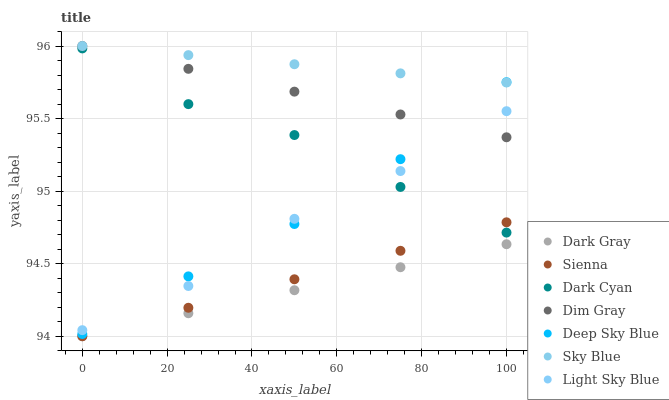Does Dark Gray have the minimum area under the curve?
Answer yes or no. Yes. Does Sky Blue have the maximum area under the curve?
Answer yes or no. Yes. Does Dim Gray have the minimum area under the curve?
Answer yes or no. No. Does Dim Gray have the maximum area under the curve?
Answer yes or no. No. Is Dark Gray the smoothest?
Answer yes or no. Yes. Is Light Sky Blue the roughest?
Answer yes or no. Yes. Is Dim Gray the smoothest?
Answer yes or no. No. Is Dim Gray the roughest?
Answer yes or no. No. Does Sienna have the lowest value?
Answer yes or no. Yes. Does Dim Gray have the lowest value?
Answer yes or no. No. Does Sky Blue have the highest value?
Answer yes or no. Yes. Does Dark Gray have the highest value?
Answer yes or no. No. Is Dark Gray less than Light Sky Blue?
Answer yes or no. Yes. Is Dim Gray greater than Sienna?
Answer yes or no. Yes. Does Light Sky Blue intersect Dim Gray?
Answer yes or no. Yes. Is Light Sky Blue less than Dim Gray?
Answer yes or no. No. Is Light Sky Blue greater than Dim Gray?
Answer yes or no. No. Does Dark Gray intersect Light Sky Blue?
Answer yes or no. No. 